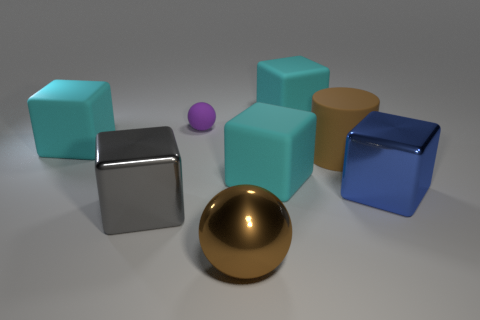Is there any other thing that has the same size as the purple thing?
Your answer should be compact. No. Do the big rubber cube that is on the left side of the brown ball and the big metallic block that is on the right side of the big gray cube have the same color?
Give a very brief answer. No. There is a big gray object; how many blue shiny cubes are to the left of it?
Your answer should be very brief. 0. How many large metallic balls are the same color as the cylinder?
Offer a very short reply. 1. Is the sphere that is to the right of the small sphere made of the same material as the gray thing?
Your answer should be very brief. Yes. How many other tiny spheres have the same material as the tiny purple ball?
Ensure brevity in your answer.  0. Are there more large cyan cubes that are in front of the tiny rubber thing than purple things?
Ensure brevity in your answer.  Yes. What is the size of the cylinder that is the same color as the big ball?
Make the answer very short. Large. Are there any tiny purple things of the same shape as the blue object?
Ensure brevity in your answer.  No. How many objects are cyan things or big purple metallic cylinders?
Your answer should be compact. 3. 